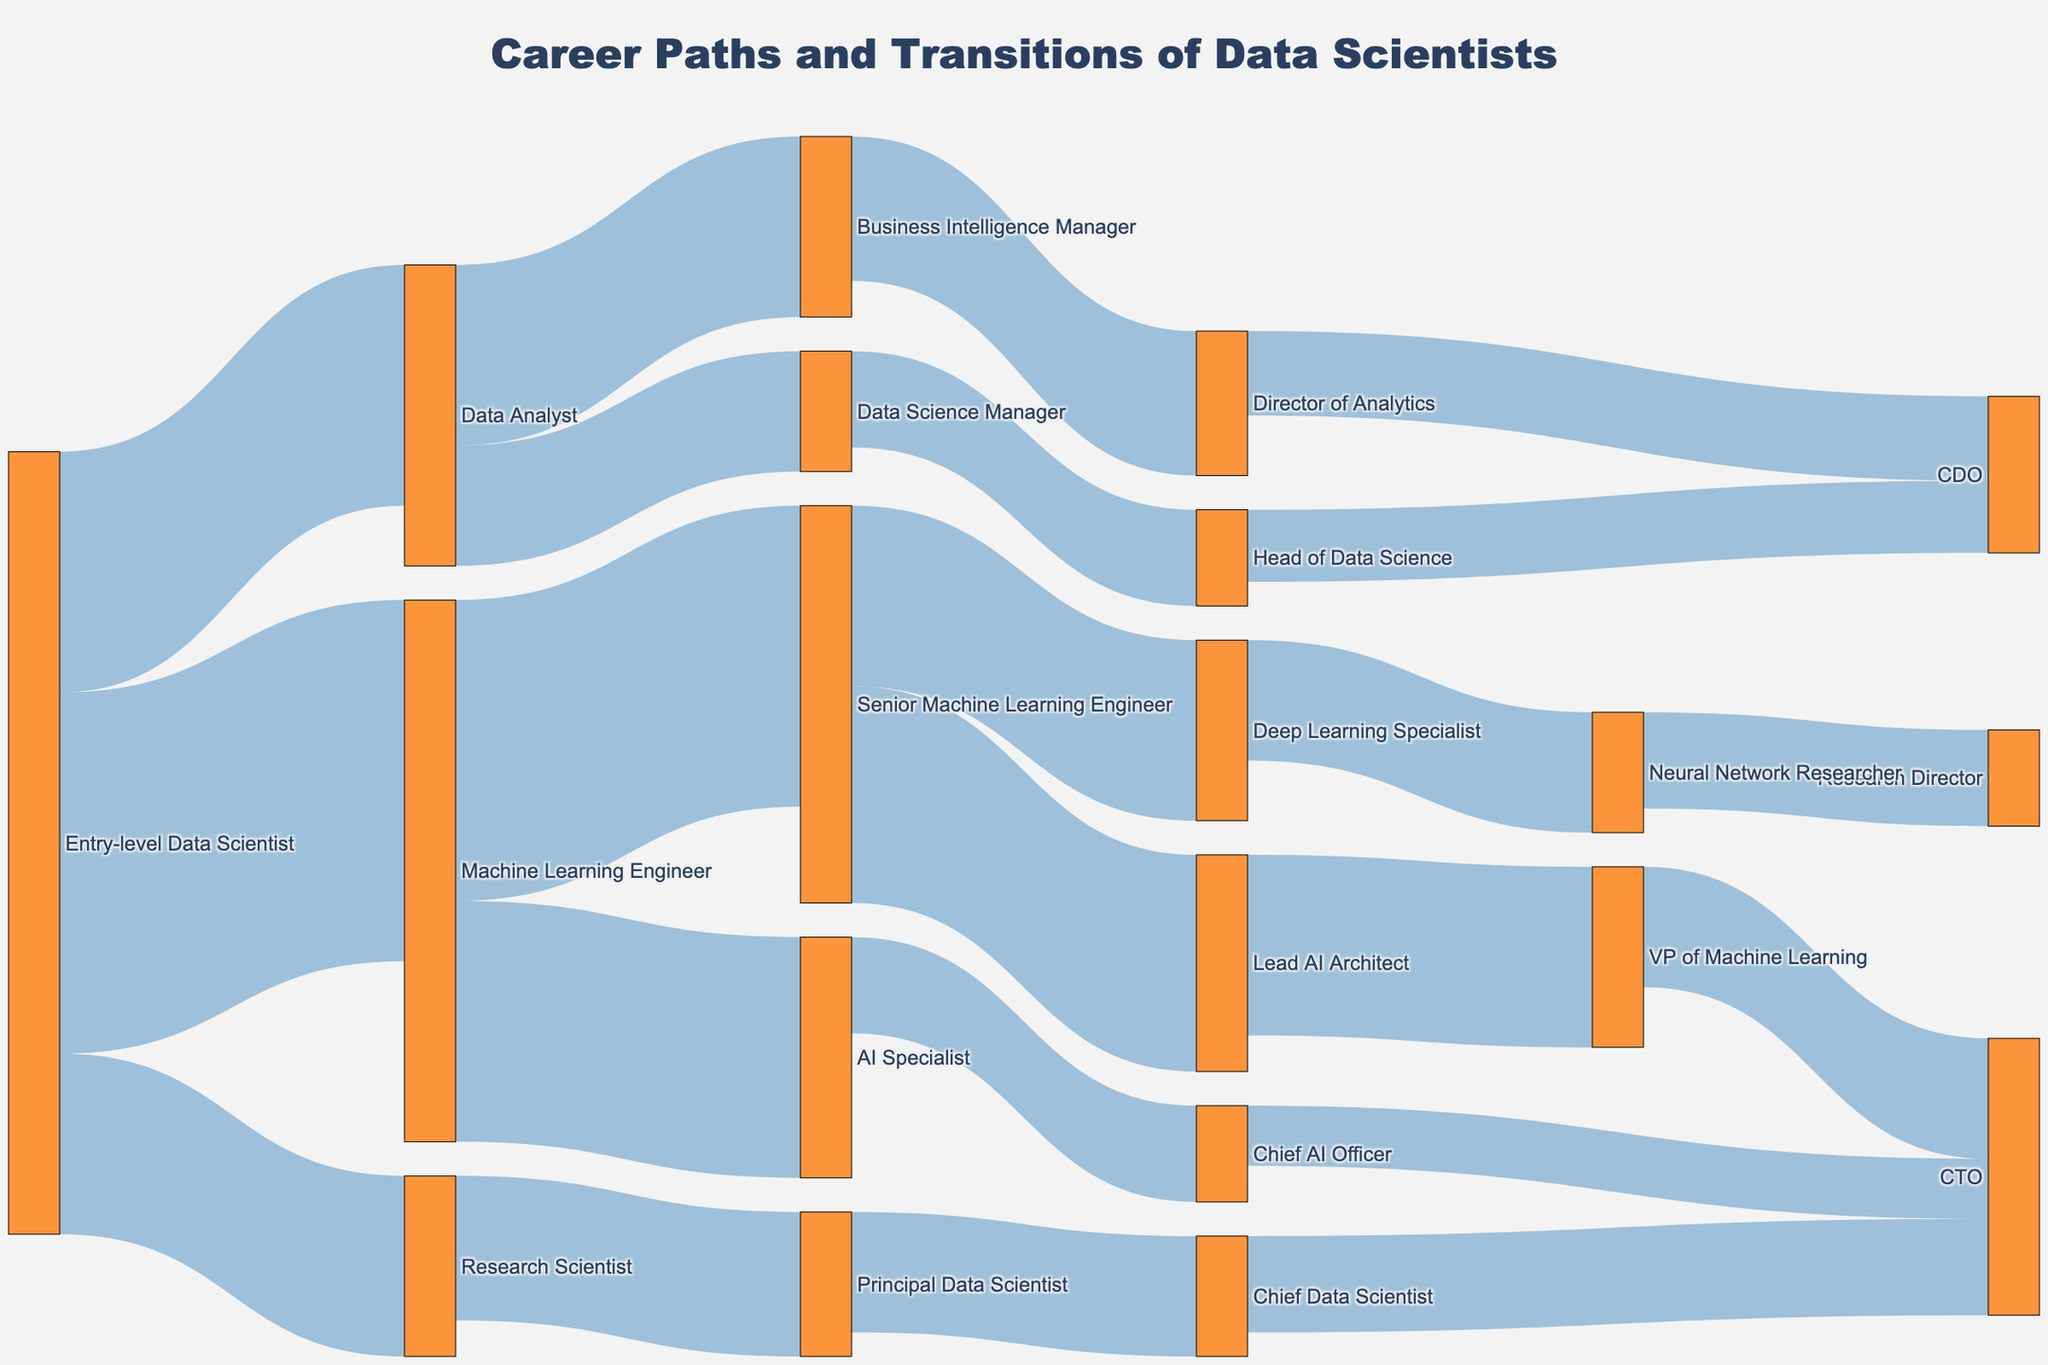What is the title of the diagram? The title is usually prominently displayed at the top of the figure. In this case, it is "Career Paths and Transitions of Data Scientists."
Answer: Career Paths and Transitions of Data Scientists Which position has the greatest number of transitions starting from an Entry-level Data Scientist? To find this, review the connections originating from "Entry-level Data Scientist" and identify the one with the highest value. The values are 30, 20, and 15. The highest is 30, leading to "Machine Learning Engineer."
Answer: Machine Learning Engineer How many career transitions lead to becoming a CTO? Count the connections that have "CTO" as the target. There are three paths: "Chief AI Officer" to "CTO" (5), "Chief Data Scientist" to "CTO" (8), and "VP of Machine Learning" to "CTO" (10). Summing these values gives 5 + 8 + 10 = 23.
Answer: 23 What are the possible next positions for a Senior Machine Learning Engineer? Look for the connections that list "Senior Machine Learning Engineer" as the source. The figure shows two target positions: "Lead AI Architect" (18) and "Deep Learning Specialist" (15).
Answer: Lead AI Architect, Deep Learning Specialist How many transition paths lead to the role of a CDO (Chief Data Officer)? Find all transitions that have "CDO" as the target. There are two paths: "Director of Analytics" to "CDO" (7) and "Head of Data Science" to "CDO" (6). The total is 7 + 6 = 13.
Answer: 13 Which position has the highest transitional value from Machine Learning Engineer? Look at the connections from "Machine Learning Engineer." The values are 25 to "Senior Machine Learning Engineer" and 20 to "AI Specialist." The highest value is 25 to "Senior Machine Learning Engineer."
Answer: Senior Machine Learning Engineer Which role leads to the most diverse set of high-level positions (roles like VP or above)? Check which intermediate role has connections to the highest number of distinct high-level roles. "Senior Machine Learning Engineer" leads to "Lead AI Architect" and "Deep Learning Specialist," and "Principal Data Scientist" directly connects to "Chief Data Scientist." However, "Lead AI Architect" itself leads to "VP of Machine Learning," which then connects to "CTO," showing diversity. Summarizing, "Lead AI Architect" ties or perhaps slightly surpasses with its diverse continuation paths.
Answer: Lead AI Architect What is the total number of career transitions originating from Data Analyst positions? Add the values of the transitions starting from "Data Analyst." The connections are to "Business Intelligence Manager" (15) and "Data Science Manager" (10). Summing these gives 15 + 10 = 25.
Answer: 25 